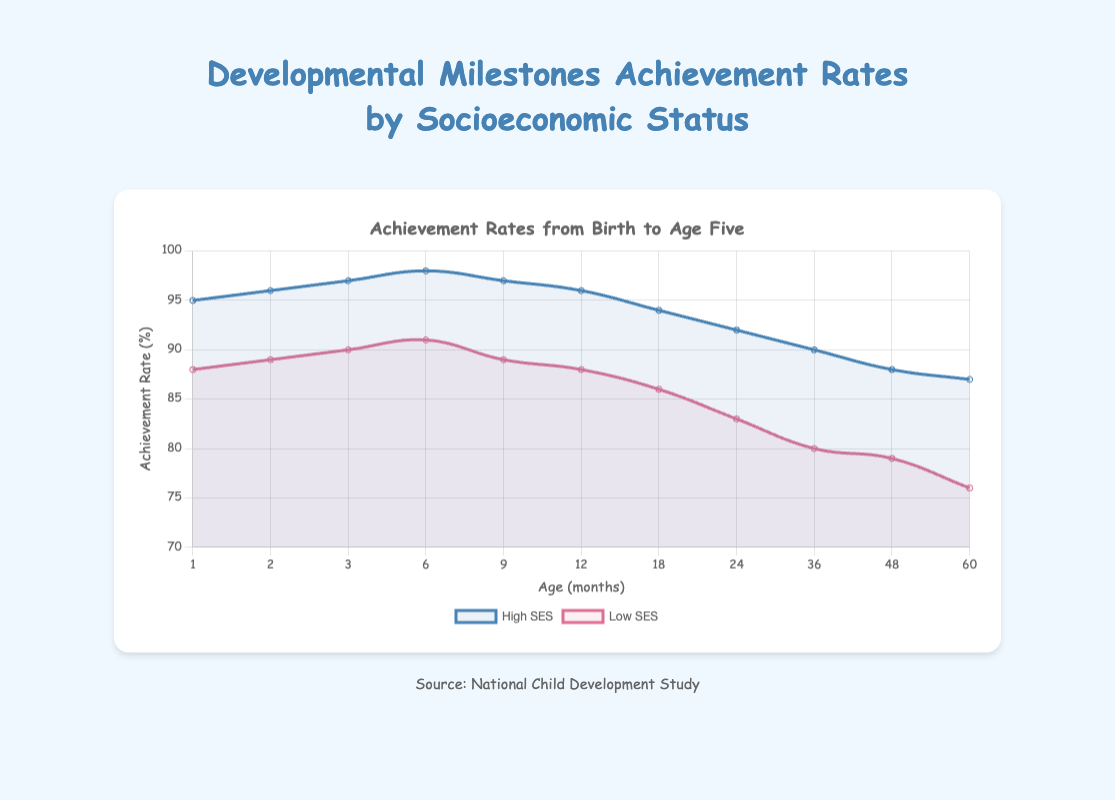What is the achievement rate of high SES children at 24 months? Look at the graph and find the point corresponding to 24 months on the x-axis, then check the value of the high SES line at that point.
Answer: 92% What is the difference in achievement rates between high SES and low SES children at 12 months? Locate the points for both high SES and low SES for 12 months on the x-axis: 96% for high SES and 88% for low SES, then subtract the low SES rate from the high SES rate: 96% - 88% = 8%.
Answer: 8% At which age do high SES children have the highest achievement rate according to the figure? Observe the high SES line and identify the age that corresponds to its peak value. The highest rate is at 6 months with 98%.
Answer: 6 months How does the achievement rate for low SES children change from 18 months to 36 months? Check the achievement rate for low SES children at 18 months (86%) and at 36 months (80%), then determine the change: 86% - 80% = 6%.
Answer: Decreases by 6% What is the average achievement rate for high SES children from ages 1 to 3 months? Sum the values for high SES children at ages 1, 2, and 3 months (95%, 96%, and 97%) and divide by 3: (95 + 96 + 97) / 3 = 96%.
Answer: 96% Which group shows a higher improvement in achievement rate from birth to 6 months? Compare the change in achievement rates from 1 month to 6 months. For high SES: 98% - 95% = 3%; for low SES: 91% - 88% = 3%. Both show the same improvement.
Answer: Both show the same improvement At 48 months, what is the difference in achievement rates between high SES and low SES children? Look at the points for both groups at age 48 months: high SES (88%) and low SES (79%). Then calculate the difference: 88% - 79% = 9%.
Answer: 9% Which SES group exhibits a steeper decline in achievement rates from 6 months to 60 months? Calculate the differences for both groups from 6 months to 60 months. High SES: 98% at 6 months to 87% at 60 months, (98 - 87 = 11); low SES: 91% at 6 months to 76% at 60 months, (91 - 76 = 15). Low SES shows a steeper decline.
Answer: Low SES At what age does the achievement rate for low SES children fall below 80%? Identify the point at which the achievement rate for low SES first drops below 80%. This happens at 36 months (80%) and 48 months (79%). So, it is just after 36 months.
Answer: After 36 months 